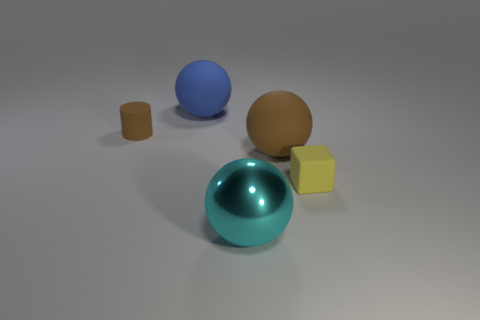What different materials do the objects in the image appear to be made of? The objects in the image seem to be rendered with various materials. The large cyan sphere appears to have a glossy, reflective surface, perhaps resembling polished metal or glass, while the tiny cylinder and the cube look to have matte textures akin to plastic or painted wood. 